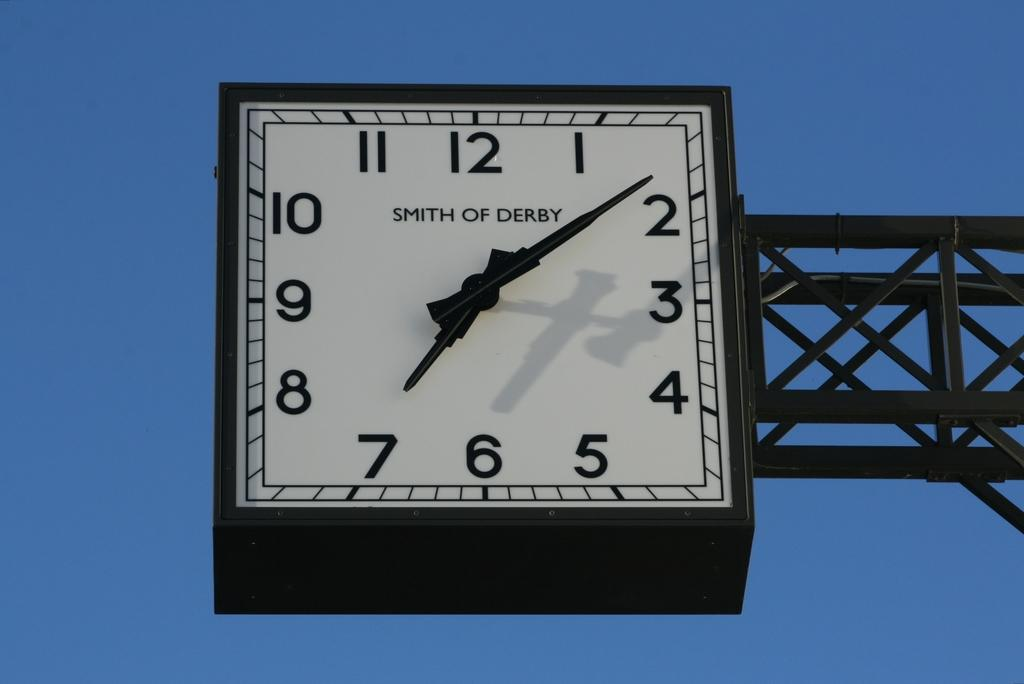<image>
Offer a succinct explanation of the picture presented. A large, black, Smith and Derby clock that is suspended in the air, reads the time as 7:08. 